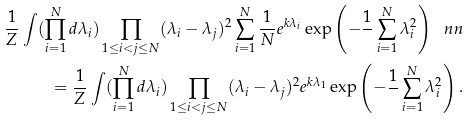<formula> <loc_0><loc_0><loc_500><loc_500>\frac { 1 } { Z } \int ( \prod _ { i = 1 } ^ { N } d \lambda _ { i } ) \prod _ { 1 \leq i < j \leq N } ( \lambda _ { i } - \lambda _ { j } ) ^ { 2 } \sum _ { i = 1 } ^ { N } \frac { 1 } { N } e ^ { k \lambda _ { i } } \exp \left ( - \frac { 1 } { } \sum _ { i = 1 } ^ { N } \lambda _ { i } ^ { 2 } \right ) \ n n \\ = \frac { 1 } { Z } \int ( \prod _ { i = 1 } ^ { N } d \lambda _ { i } ) \prod _ { 1 \leq i < j \leq N } ( \lambda _ { i } - \lambda _ { j } ) ^ { 2 } e ^ { k \lambda _ { 1 } } \exp \left ( - \frac { 1 } { } \sum _ { i = 1 } ^ { N } \lambda _ { i } ^ { 2 } \right ) .</formula> 